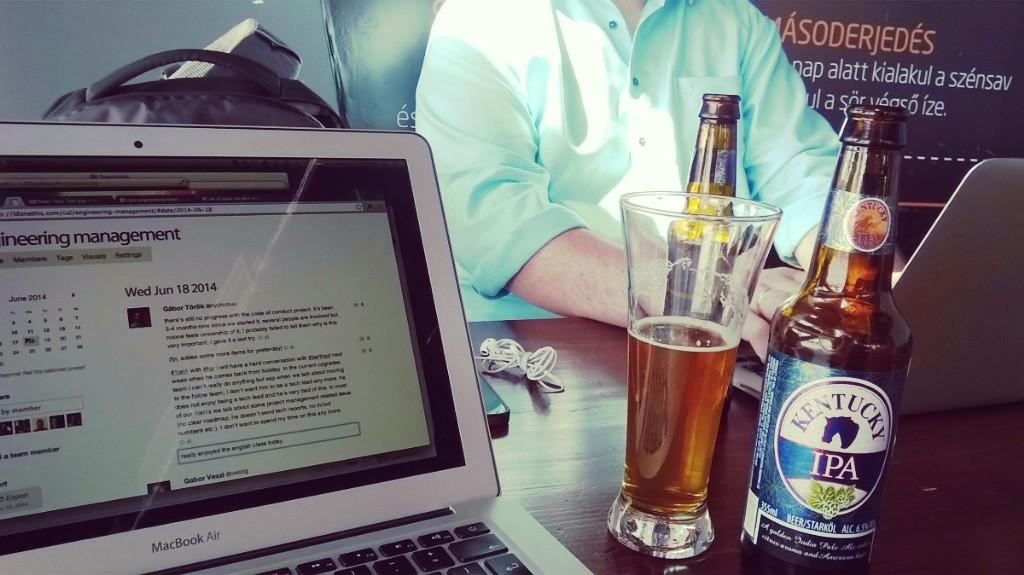Provide a one-sentence caption for the provided image. A bottle of Kentucky IPA is next to a laptop. 